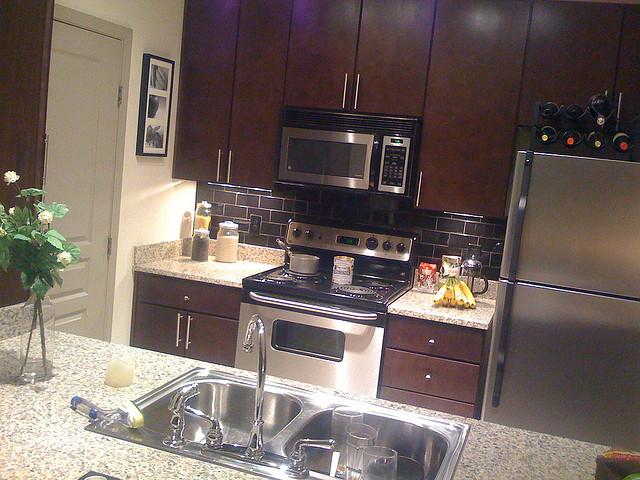What room is this?
Concise answer only. Kitchen. Is this a brightly-lit kitchen?
Short answer required. Yes. Is the kitchen clean?
Answer briefly. Yes. Are there dishes on the stove?
Be succinct. Yes. Are there flowers on the counter?
Answer briefly. Yes. How many bottles of wine do you see?
Concise answer only. 5. 